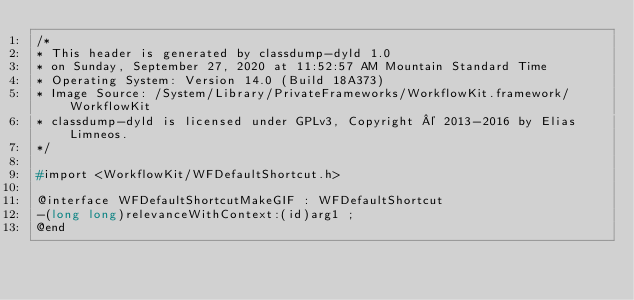<code> <loc_0><loc_0><loc_500><loc_500><_C_>/*
* This header is generated by classdump-dyld 1.0
* on Sunday, September 27, 2020 at 11:52:57 AM Mountain Standard Time
* Operating System: Version 14.0 (Build 18A373)
* Image Source: /System/Library/PrivateFrameworks/WorkflowKit.framework/WorkflowKit
* classdump-dyld is licensed under GPLv3, Copyright © 2013-2016 by Elias Limneos.
*/

#import <WorkflowKit/WFDefaultShortcut.h>

@interface WFDefaultShortcutMakeGIF : WFDefaultShortcut
-(long long)relevanceWithContext:(id)arg1 ;
@end

</code> 